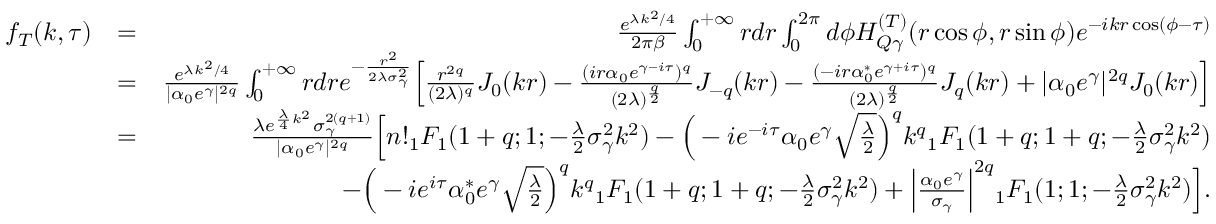<formula> <loc_0><loc_0><loc_500><loc_500>\begin{array} { r l r } { f _ { T } ( k , \tau ) } & { = } & { \frac { e ^ { \lambda k ^ { 2 } / 4 } } { 2 \pi \beta } \int _ { 0 } ^ { + \infty } r d r \int _ { 0 } ^ { 2 \pi } d \phi H _ { Q \gamma } ^ { ( T ) } ( r \cos \phi , r \sin \phi ) e ^ { - i k r \cos ( \phi - \tau ) } } \\ & { = } & { \frac { e ^ { \lambda k ^ { 2 } / 4 } } { | \alpha _ { 0 } e ^ { \gamma } | ^ { 2 q } } \int _ { 0 } ^ { + \infty } r d r e ^ { - \frac { r ^ { 2 } } { 2 \lambda \sigma _ { \gamma } ^ { 2 } } } \left [ \frac { r ^ { 2 q } } { ( 2 \lambda ) ^ { q } } J _ { 0 } ( k r ) - \frac { ( i r \alpha _ { 0 } e ^ { \gamma - i \tau } ) ^ { q } } { ( 2 \lambda ) ^ { \frac { q } { 2 } } } J _ { - q } ( k r ) - \frac { ( - i r \alpha _ { 0 } ^ { * } e ^ { \gamma + i \tau } ) ^ { q } } { ( 2 \lambda ) ^ { \frac { q } { 2 } } } J _ { q } ( k r ) + | \alpha _ { 0 } e ^ { \gamma } | ^ { 2 q } J _ { 0 } ( k r ) \right ] } \\ & { = } & { \frac { \lambda e ^ { \frac { \lambda } { 4 } k ^ { 2 } } \sigma _ { \gamma } ^ { 2 ( q + 1 ) } } { | \alpha _ { 0 } e ^ { \gamma } | ^ { 2 q } } \left [ n ! { _ { 1 } F _ { 1 } } ( 1 + q ; 1 ; - \frac { \lambda } { 2 } \sigma _ { \gamma } ^ { 2 } k ^ { 2 } ) - \left ( - i e ^ { - i \tau } \alpha _ { 0 } e ^ { \gamma } \sqrt { \frac { \lambda } { 2 } } \right ) ^ { q } k ^ { q } { _ { 1 } F _ { 1 } } ( 1 + q ; 1 + q ; - \frac { \lambda } { 2 } \sigma _ { \gamma } ^ { 2 } k ^ { 2 } ) } \\ & { - \left ( - i e ^ { i \tau } \alpha _ { 0 } ^ { * } e ^ { \gamma } \sqrt { \frac { \lambda } { 2 } } \right ) ^ { q } k ^ { q } { _ { 1 } F _ { 1 } } ( 1 + q ; 1 + q ; - \frac { \lambda } { 2 } \sigma _ { \gamma } ^ { 2 } k ^ { 2 } ) + \left | \frac { \alpha _ { 0 } e ^ { \gamma } } { \sigma _ { \gamma } } \right | ^ { 2 q } { _ { 1 } F _ { 1 } } ( 1 ; 1 ; - \frac { \lambda } { 2 } \sigma _ { \gamma } ^ { 2 } k ^ { 2 } ) \right ] . } \end{array}</formula> 